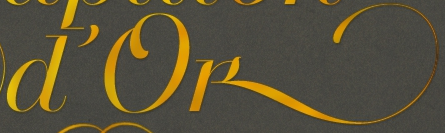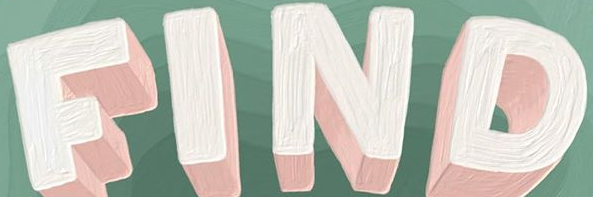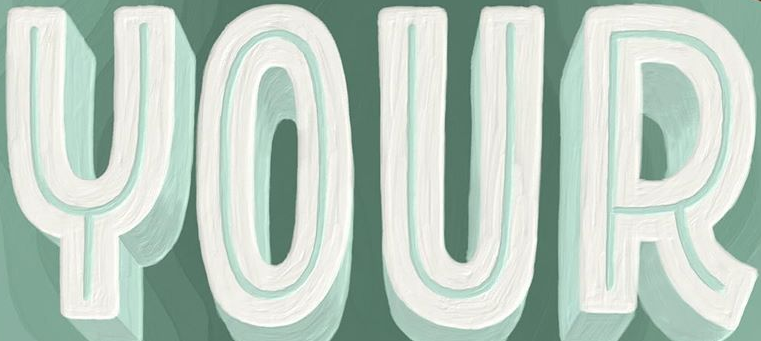Transcribe the words shown in these images in order, separated by a semicolon. D'ok; FIND; YOUR 